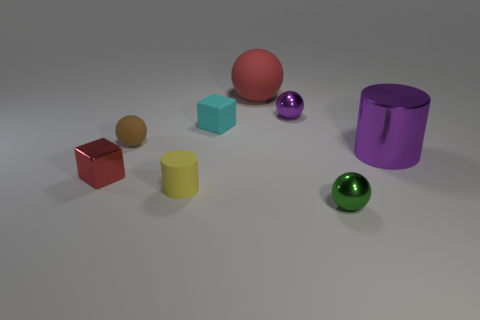Is the number of brown spheres less than the number of small rubber objects?
Provide a succinct answer. Yes. What is the shape of the cyan matte object behind the cylinder that is in front of the big thing right of the red rubber thing?
Give a very brief answer. Cube. How many things are either spheres in front of the tiny purple metal object or small objects that are in front of the matte cylinder?
Offer a very short reply. 2. There is a tiny brown ball; are there any large purple objects behind it?
Give a very brief answer. No. How many objects are large purple metal things in front of the small brown thing or purple shiny cylinders?
Give a very brief answer. 1. How many yellow things are tiny cylinders or small metal balls?
Provide a short and direct response. 1. What number of other objects are there of the same color as the tiny matte sphere?
Offer a terse response. 0. Are there fewer tiny matte balls to the left of the small brown sphere than tiny cyan cubes?
Ensure brevity in your answer.  Yes. There is a small metal thing behind the large thing to the right of the tiny shiny thing behind the rubber cube; what color is it?
Give a very brief answer. Purple. The other thing that is the same shape as the small yellow matte thing is what size?
Keep it short and to the point. Large. 